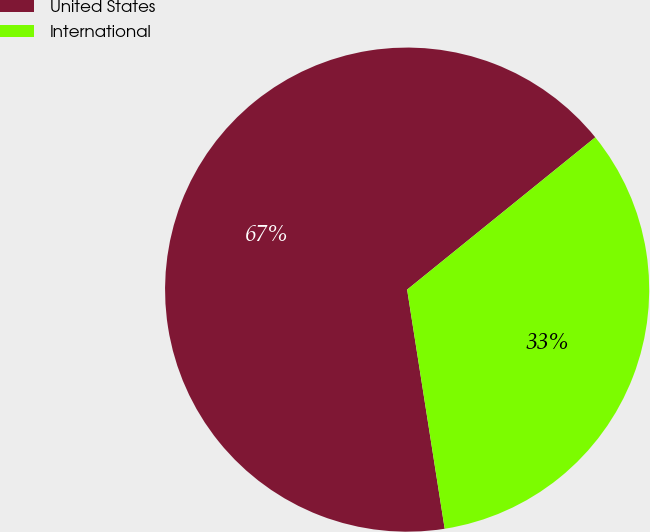Convert chart. <chart><loc_0><loc_0><loc_500><loc_500><pie_chart><fcel>United States<fcel>International<nl><fcel>66.65%<fcel>33.35%<nl></chart> 